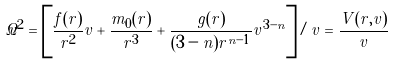Convert formula to latex. <formula><loc_0><loc_0><loc_500><loc_500>\dot { v } ^ { 2 } = \left [ \frac { f ( r ) } { r ^ { 2 } } v + \frac { m _ { 0 } ( r ) } { r ^ { 3 } } + \frac { g ( r ) } { ( 3 - n ) r ^ { n - 1 } } v ^ { 3 - n } \right ] / v = \frac { V ( r , v ) } { v }</formula> 